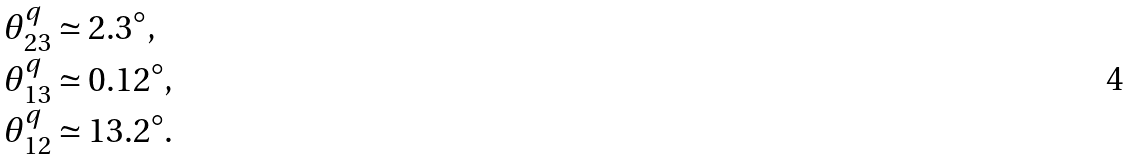<formula> <loc_0><loc_0><loc_500><loc_500>& \theta ^ { q } _ { 2 3 } \simeq 2 . 3 ^ { \circ } , \\ & \theta ^ { q } _ { 1 3 } \simeq 0 . 1 2 ^ { \circ } , \\ & \theta ^ { q } _ { 1 2 } \simeq 1 3 . 2 ^ { \circ } .</formula> 